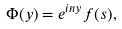<formula> <loc_0><loc_0><loc_500><loc_500>\Phi ( y ) = e ^ { i n y } f ( s ) ,</formula> 